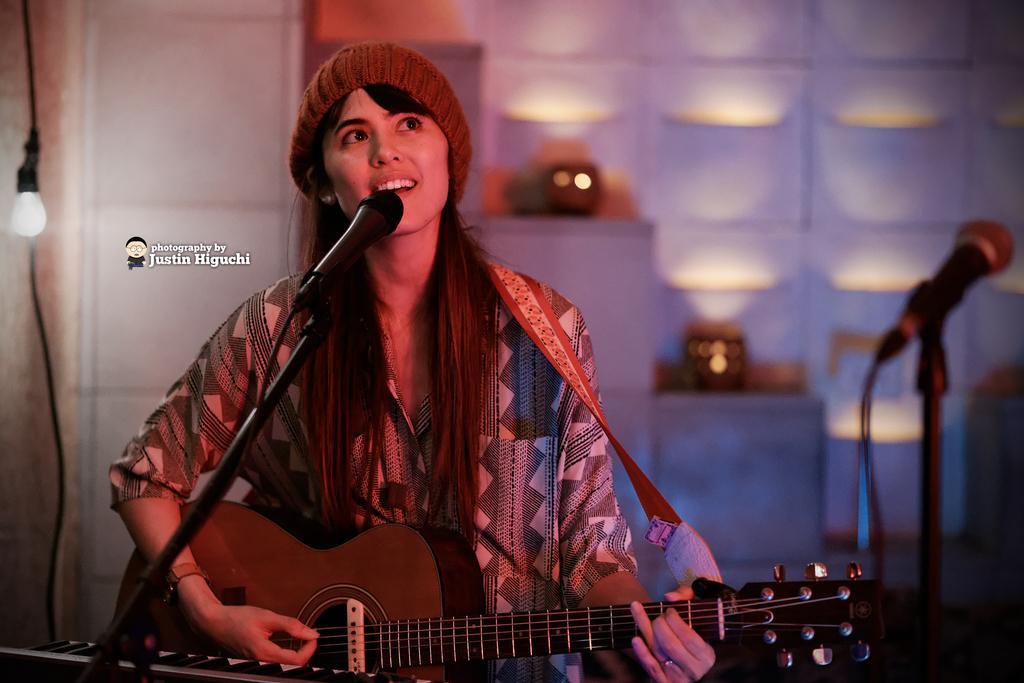In one or two sentences, can you explain what this image depicts? This is a picture of a girl who is holding a guitar and playing it of a mike. She wore a black and white shirt and also there is an other mike in the picture. 